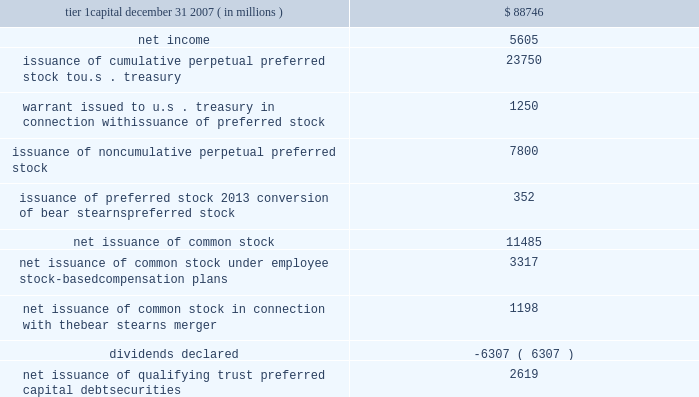Management 2019s discussion and analysis 84 jpmorgan chase & co .
/ 2008 annual report tier 1 capital was $ 136.1 billion at december 31 , 2008 , compared with $ 88.7 billion at december 31 , 2007 , an increase of $ 47.4 billion .
The table presents the changes in tier 1 capital for the year ended december 31 , 2008. .
Additional information regarding the firm 2019s capital ratios and the federal regulatory capital standards to which it is subject , and the capital ratios for the firm 2019s significant banking subsidiaries at december 31 , 2008 and 2007 , are presented in note 30 on pages 212 2013213 of this annual report .
Capital purchase program pursuant to the capital purchase program , on october 28 , 2008 , the firm issued to the u.s .
Treasury , for total proceeds of $ 25.0 billion , ( i ) 2.5 million shares of series k preferred stock , and ( ii ) a warrant to pur- chase up to 88401697 shares of the firm 2019s common stock , at an exer- cise price of $ 42.42 per share , subject to certain antidilution and other adjustments .
The series k preferred stock qualifies as tier 1 capital .
The series k preferred stock bears cumulative dividends at a rate of 5% ( 5 % ) per year for the first five years and 9% ( 9 % ) per year thereafter .
The series k preferred stock ranks equally with the firm 2019s existing 6.15% ( 6.15 % ) cumulative preferred stock , series e ; 5.72% ( 5.72 % ) cumulative preferred stock , series f ; 5.49% ( 5.49 % ) cumulative preferred stock , series g ; fixed- to-floating rate noncumulative perpetual preferred stock , series i ; and 8.63% ( 8.63 % ) noncumulative perpetual preferred stock , series j , in terms of dividend payments and upon liquidation of the firm .
Any accrued and unpaid dividends on the series k preferred stock must be fully paid before dividends may be declared or paid on stock ranking junior or equally with the series k preferred stock .
Pursuant to the capital purchase program , until october 28 , 2011 , the u.s .
Treasury 2019s consent is required for any increase in dividends on the firm 2019s common stock from the amount of the last quarterly stock div- idend declared by the firm prior to october 14 , 2008 , unless the series k preferred stock is redeemed in whole before then , or the u.s .
Treasury has transferred all of the series k preferred stock it owns to third parties .
The firm may not repurchase or redeem any common stock or other equity securities of the firm , or any trust preferred securities issued by the firm or any of its affiliates , without the prior consent of the u.s .
Treasury ( other than ( i ) repurchases of the series k preferred stock and ( ii ) repurchases of junior preferred shares or common stock in connection with any employee benefit plan in the ordinary course of business consistent with past practice ) .
Basel ii the minimum risk-based capital requirements adopted by the u.s .
Federal banking agencies follow the capital accord of the basel committee on banking supervision .
In 2004 , the basel committee published a revision to the accord ( 201cbasel ii 201d ) .
The goal of the new basel ii framework is to provide more risk-sensitive regulatory capital calculations and promote enhanced risk management practices among large , internationally active banking organizations .
U.s .
Bank- ing regulators published a final basel ii rule in december 2007 , which will require jpmorgan chase to implement basel ii at the holding company level , as well as at certain of its key u.s .
Bank subsidiaries .
Prior to full implementation of the new basel ii framework , jpmorgan chase will be required to complete a qualification period of four consecutive quarters during which it will need to demonstrate that it meets the requirements of the new rule to the satisfaction of its primary u.s .
Banking regulators .
The u.s .
Implementation timetable consists of the qualification period , starting any time between april 1 , 2008 , and april 1 , 2010 , followed by a minimum transition period of three years .
During the transition period , basel ii risk-based capital requirements cannot fall below certain floors based on current ( 201cbasel l 201d ) regulations .
Jpmorgan chase expects to be in compliance with all relevant basel ii rules within the estab- lished timelines .
In addition , the firm has adopted , and will continue to adopt , based upon various established timelines , basel ii in certain non-u.s .
Jurisdictions , as required .
Broker-dealer regulatory capital jpmorgan chase 2019s principal u.s .
Broker-dealer subsidiaries are j.p .
Morgan securities inc .
( 201cjpmorgan securities 201d ) and j.p .
Morgan clearing corp .
( formerly known as bear stearns securities corp. ) .
Jpmorgan securities and j.p .
Morgan clearing corp .
Are each subject to rule 15c3-1 under the securities exchange act of 1934 ( 201cnet capital rule 201d ) .
Jpmorgan securities and j.p .
Morgan clearing corp .
Are also registered as futures commission merchants and subject to rule 1.17 under the commodity futures trading commission ( 201ccftc 201d ) .
Jpmorgan securities and j.p .
Morgan clearing corp .
Have elected to compute their minimum net capital requirements in accordance with the 201calternative net capital requirement 201d of the net capital rule .
At december 31 , 2008 , jpmorgan securities 2019 net capital , as defined by the net capital rule , of $ 7.2 billion exceeded the minimum require- ment by $ 6.6 billion .
In addition to its net capital requirements , jpmorgan securities is required to hold tentative net capital in excess jpmorgan chase & co .
/ 2008 annual report84 .
What percentage of the increase in tier 1 capital was due to net income? 
Computations: (5605 / 47358)
Answer: 0.11835. 